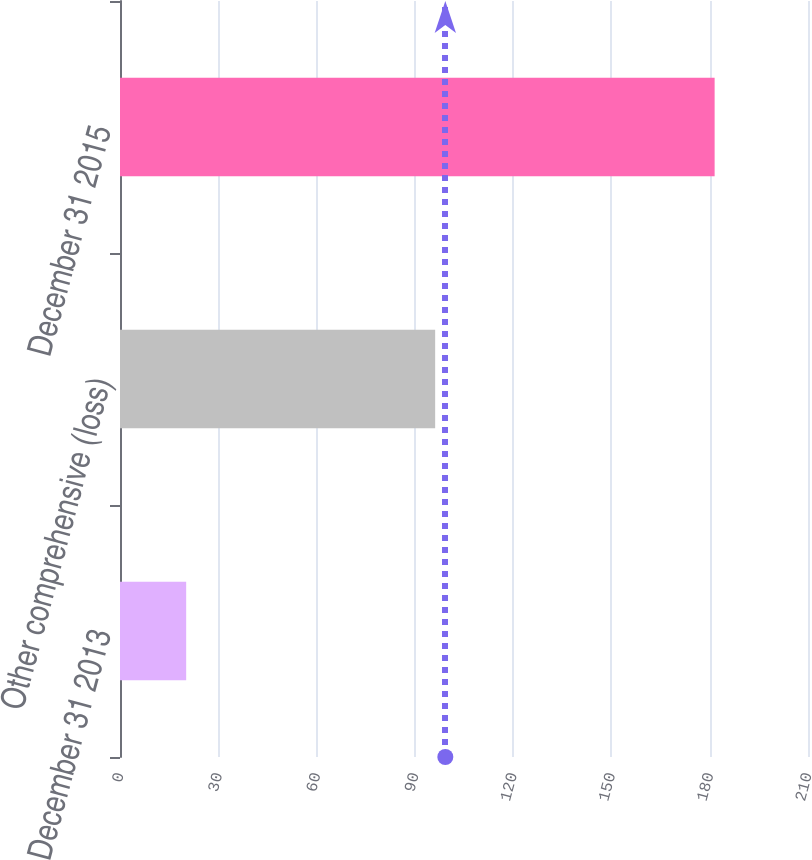Convert chart to OTSL. <chart><loc_0><loc_0><loc_500><loc_500><bar_chart><fcel>December 31 2013<fcel>Other comprehensive (loss)<fcel>December 31 2015<nl><fcel>20.2<fcel>96.2<fcel>181.5<nl></chart> 